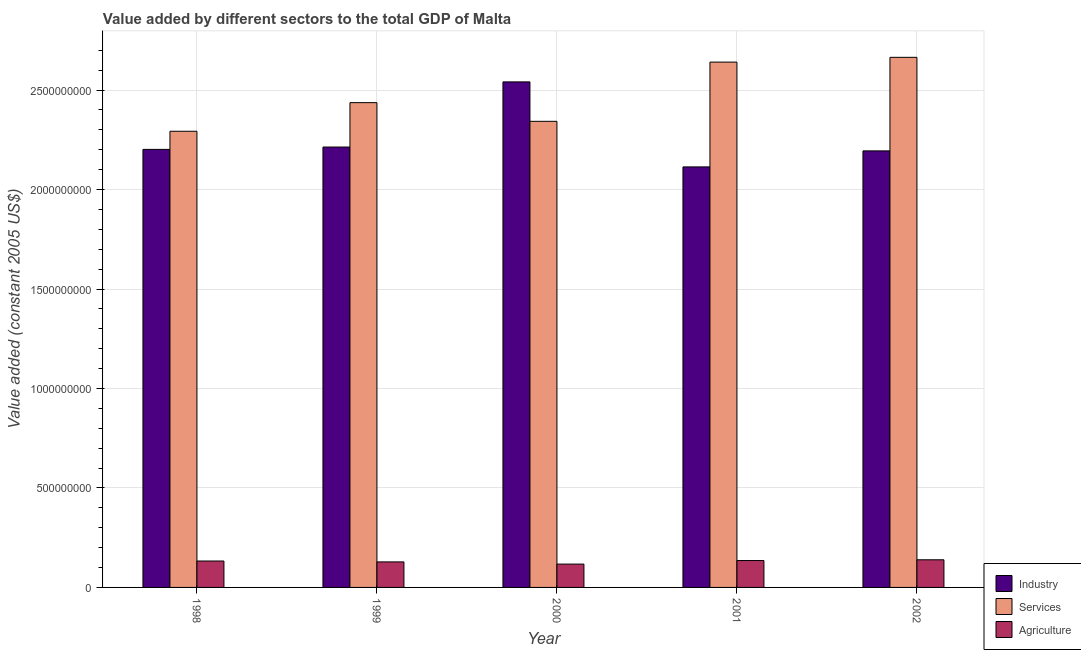How many groups of bars are there?
Ensure brevity in your answer.  5. Are the number of bars per tick equal to the number of legend labels?
Give a very brief answer. Yes. Are the number of bars on each tick of the X-axis equal?
Provide a short and direct response. Yes. How many bars are there on the 5th tick from the left?
Your answer should be compact. 3. How many bars are there on the 1st tick from the right?
Ensure brevity in your answer.  3. What is the label of the 4th group of bars from the left?
Ensure brevity in your answer.  2001. In how many cases, is the number of bars for a given year not equal to the number of legend labels?
Make the answer very short. 0. What is the value added by agricultural sector in 1998?
Your response must be concise. 1.33e+08. Across all years, what is the maximum value added by agricultural sector?
Make the answer very short. 1.39e+08. Across all years, what is the minimum value added by services?
Offer a terse response. 2.29e+09. In which year was the value added by industrial sector maximum?
Give a very brief answer. 2000. What is the total value added by agricultural sector in the graph?
Provide a succinct answer. 6.52e+08. What is the difference between the value added by industrial sector in 1998 and that in 2000?
Give a very brief answer. -3.39e+08. What is the difference between the value added by services in 2000 and the value added by industrial sector in 2001?
Give a very brief answer. -2.98e+08. What is the average value added by services per year?
Give a very brief answer. 2.48e+09. In how many years, is the value added by services greater than 900000000 US$?
Provide a short and direct response. 5. What is the ratio of the value added by services in 1998 to that in 2001?
Make the answer very short. 0.87. What is the difference between the highest and the second highest value added by services?
Provide a succinct answer. 2.40e+07. What is the difference between the highest and the lowest value added by industrial sector?
Provide a short and direct response. 4.27e+08. Is the sum of the value added by industrial sector in 1999 and 2001 greater than the maximum value added by services across all years?
Your answer should be very brief. Yes. What does the 1st bar from the left in 2001 represents?
Your response must be concise. Industry. What does the 2nd bar from the right in 1999 represents?
Provide a short and direct response. Services. Is it the case that in every year, the sum of the value added by industrial sector and value added by services is greater than the value added by agricultural sector?
Provide a succinct answer. Yes. How many years are there in the graph?
Provide a succinct answer. 5. Are the values on the major ticks of Y-axis written in scientific E-notation?
Your response must be concise. No. Does the graph contain any zero values?
Your answer should be very brief. No. Does the graph contain grids?
Offer a very short reply. Yes. What is the title of the graph?
Your response must be concise. Value added by different sectors to the total GDP of Malta. What is the label or title of the Y-axis?
Ensure brevity in your answer.  Value added (constant 2005 US$). What is the Value added (constant 2005 US$) of Industry in 1998?
Offer a terse response. 2.20e+09. What is the Value added (constant 2005 US$) of Services in 1998?
Provide a short and direct response. 2.29e+09. What is the Value added (constant 2005 US$) in Agriculture in 1998?
Give a very brief answer. 1.33e+08. What is the Value added (constant 2005 US$) of Industry in 1999?
Your answer should be compact. 2.21e+09. What is the Value added (constant 2005 US$) in Services in 1999?
Your response must be concise. 2.44e+09. What is the Value added (constant 2005 US$) of Agriculture in 1999?
Ensure brevity in your answer.  1.28e+08. What is the Value added (constant 2005 US$) of Industry in 2000?
Your response must be concise. 2.54e+09. What is the Value added (constant 2005 US$) in Services in 2000?
Offer a very short reply. 2.34e+09. What is the Value added (constant 2005 US$) in Agriculture in 2000?
Give a very brief answer. 1.17e+08. What is the Value added (constant 2005 US$) of Industry in 2001?
Provide a short and direct response. 2.11e+09. What is the Value added (constant 2005 US$) in Services in 2001?
Offer a terse response. 2.64e+09. What is the Value added (constant 2005 US$) in Agriculture in 2001?
Your response must be concise. 1.35e+08. What is the Value added (constant 2005 US$) in Industry in 2002?
Keep it short and to the point. 2.19e+09. What is the Value added (constant 2005 US$) of Services in 2002?
Give a very brief answer. 2.66e+09. What is the Value added (constant 2005 US$) of Agriculture in 2002?
Your answer should be compact. 1.39e+08. Across all years, what is the maximum Value added (constant 2005 US$) of Industry?
Your answer should be compact. 2.54e+09. Across all years, what is the maximum Value added (constant 2005 US$) in Services?
Offer a very short reply. 2.66e+09. Across all years, what is the maximum Value added (constant 2005 US$) of Agriculture?
Your answer should be very brief. 1.39e+08. Across all years, what is the minimum Value added (constant 2005 US$) of Industry?
Provide a succinct answer. 2.11e+09. Across all years, what is the minimum Value added (constant 2005 US$) in Services?
Your response must be concise. 2.29e+09. Across all years, what is the minimum Value added (constant 2005 US$) of Agriculture?
Your answer should be very brief. 1.17e+08. What is the total Value added (constant 2005 US$) in Industry in the graph?
Keep it short and to the point. 1.13e+1. What is the total Value added (constant 2005 US$) of Services in the graph?
Offer a terse response. 1.24e+1. What is the total Value added (constant 2005 US$) of Agriculture in the graph?
Provide a short and direct response. 6.52e+08. What is the difference between the Value added (constant 2005 US$) of Industry in 1998 and that in 1999?
Your answer should be compact. -1.18e+07. What is the difference between the Value added (constant 2005 US$) in Services in 1998 and that in 1999?
Your answer should be very brief. -1.44e+08. What is the difference between the Value added (constant 2005 US$) of Agriculture in 1998 and that in 1999?
Provide a succinct answer. 4.47e+06. What is the difference between the Value added (constant 2005 US$) in Industry in 1998 and that in 2000?
Offer a very short reply. -3.39e+08. What is the difference between the Value added (constant 2005 US$) of Services in 1998 and that in 2000?
Offer a very short reply. -4.99e+07. What is the difference between the Value added (constant 2005 US$) of Agriculture in 1998 and that in 2000?
Give a very brief answer. 1.54e+07. What is the difference between the Value added (constant 2005 US$) of Industry in 1998 and that in 2001?
Make the answer very short. 8.80e+07. What is the difference between the Value added (constant 2005 US$) in Services in 1998 and that in 2001?
Make the answer very short. -3.48e+08. What is the difference between the Value added (constant 2005 US$) in Agriculture in 1998 and that in 2001?
Make the answer very short. -2.40e+06. What is the difference between the Value added (constant 2005 US$) of Industry in 1998 and that in 2002?
Provide a short and direct response. 7.51e+06. What is the difference between the Value added (constant 2005 US$) in Services in 1998 and that in 2002?
Offer a terse response. -3.72e+08. What is the difference between the Value added (constant 2005 US$) in Agriculture in 1998 and that in 2002?
Your response must be concise. -6.11e+06. What is the difference between the Value added (constant 2005 US$) of Industry in 1999 and that in 2000?
Ensure brevity in your answer.  -3.28e+08. What is the difference between the Value added (constant 2005 US$) of Services in 1999 and that in 2000?
Make the answer very short. 9.39e+07. What is the difference between the Value added (constant 2005 US$) in Agriculture in 1999 and that in 2000?
Provide a succinct answer. 1.10e+07. What is the difference between the Value added (constant 2005 US$) in Industry in 1999 and that in 2001?
Provide a succinct answer. 9.98e+07. What is the difference between the Value added (constant 2005 US$) of Services in 1999 and that in 2001?
Ensure brevity in your answer.  -2.04e+08. What is the difference between the Value added (constant 2005 US$) in Agriculture in 1999 and that in 2001?
Your response must be concise. -6.88e+06. What is the difference between the Value added (constant 2005 US$) of Industry in 1999 and that in 2002?
Your answer should be very brief. 1.93e+07. What is the difference between the Value added (constant 2005 US$) of Services in 1999 and that in 2002?
Provide a short and direct response. -2.28e+08. What is the difference between the Value added (constant 2005 US$) in Agriculture in 1999 and that in 2002?
Offer a terse response. -1.06e+07. What is the difference between the Value added (constant 2005 US$) in Industry in 2000 and that in 2001?
Make the answer very short. 4.27e+08. What is the difference between the Value added (constant 2005 US$) of Services in 2000 and that in 2001?
Offer a very short reply. -2.98e+08. What is the difference between the Value added (constant 2005 US$) of Agriculture in 2000 and that in 2001?
Your answer should be compact. -1.78e+07. What is the difference between the Value added (constant 2005 US$) of Industry in 2000 and that in 2002?
Offer a terse response. 3.47e+08. What is the difference between the Value added (constant 2005 US$) of Services in 2000 and that in 2002?
Your answer should be compact. -3.22e+08. What is the difference between the Value added (constant 2005 US$) of Agriculture in 2000 and that in 2002?
Your response must be concise. -2.15e+07. What is the difference between the Value added (constant 2005 US$) in Industry in 2001 and that in 2002?
Make the answer very short. -8.05e+07. What is the difference between the Value added (constant 2005 US$) of Services in 2001 and that in 2002?
Make the answer very short. -2.40e+07. What is the difference between the Value added (constant 2005 US$) of Agriculture in 2001 and that in 2002?
Give a very brief answer. -3.71e+06. What is the difference between the Value added (constant 2005 US$) of Industry in 1998 and the Value added (constant 2005 US$) of Services in 1999?
Offer a very short reply. -2.35e+08. What is the difference between the Value added (constant 2005 US$) of Industry in 1998 and the Value added (constant 2005 US$) of Agriculture in 1999?
Offer a terse response. 2.07e+09. What is the difference between the Value added (constant 2005 US$) in Services in 1998 and the Value added (constant 2005 US$) in Agriculture in 1999?
Keep it short and to the point. 2.16e+09. What is the difference between the Value added (constant 2005 US$) of Industry in 1998 and the Value added (constant 2005 US$) of Services in 2000?
Ensure brevity in your answer.  -1.41e+08. What is the difference between the Value added (constant 2005 US$) of Industry in 1998 and the Value added (constant 2005 US$) of Agriculture in 2000?
Your answer should be compact. 2.08e+09. What is the difference between the Value added (constant 2005 US$) of Services in 1998 and the Value added (constant 2005 US$) of Agriculture in 2000?
Make the answer very short. 2.18e+09. What is the difference between the Value added (constant 2005 US$) in Industry in 1998 and the Value added (constant 2005 US$) in Services in 2001?
Provide a short and direct response. -4.39e+08. What is the difference between the Value added (constant 2005 US$) of Industry in 1998 and the Value added (constant 2005 US$) of Agriculture in 2001?
Offer a very short reply. 2.07e+09. What is the difference between the Value added (constant 2005 US$) in Services in 1998 and the Value added (constant 2005 US$) in Agriculture in 2001?
Make the answer very short. 2.16e+09. What is the difference between the Value added (constant 2005 US$) of Industry in 1998 and the Value added (constant 2005 US$) of Services in 2002?
Your answer should be very brief. -4.63e+08. What is the difference between the Value added (constant 2005 US$) in Industry in 1998 and the Value added (constant 2005 US$) in Agriculture in 2002?
Give a very brief answer. 2.06e+09. What is the difference between the Value added (constant 2005 US$) in Services in 1998 and the Value added (constant 2005 US$) in Agriculture in 2002?
Offer a very short reply. 2.15e+09. What is the difference between the Value added (constant 2005 US$) in Industry in 1999 and the Value added (constant 2005 US$) in Services in 2000?
Your response must be concise. -1.29e+08. What is the difference between the Value added (constant 2005 US$) of Industry in 1999 and the Value added (constant 2005 US$) of Agriculture in 2000?
Ensure brevity in your answer.  2.10e+09. What is the difference between the Value added (constant 2005 US$) of Services in 1999 and the Value added (constant 2005 US$) of Agriculture in 2000?
Your response must be concise. 2.32e+09. What is the difference between the Value added (constant 2005 US$) in Industry in 1999 and the Value added (constant 2005 US$) in Services in 2001?
Make the answer very short. -4.27e+08. What is the difference between the Value added (constant 2005 US$) in Industry in 1999 and the Value added (constant 2005 US$) in Agriculture in 2001?
Provide a succinct answer. 2.08e+09. What is the difference between the Value added (constant 2005 US$) in Services in 1999 and the Value added (constant 2005 US$) in Agriculture in 2001?
Provide a succinct answer. 2.30e+09. What is the difference between the Value added (constant 2005 US$) in Industry in 1999 and the Value added (constant 2005 US$) in Services in 2002?
Ensure brevity in your answer.  -4.51e+08. What is the difference between the Value added (constant 2005 US$) in Industry in 1999 and the Value added (constant 2005 US$) in Agriculture in 2002?
Provide a short and direct response. 2.07e+09. What is the difference between the Value added (constant 2005 US$) in Services in 1999 and the Value added (constant 2005 US$) in Agriculture in 2002?
Your response must be concise. 2.30e+09. What is the difference between the Value added (constant 2005 US$) of Industry in 2000 and the Value added (constant 2005 US$) of Services in 2001?
Ensure brevity in your answer.  -9.95e+07. What is the difference between the Value added (constant 2005 US$) of Industry in 2000 and the Value added (constant 2005 US$) of Agriculture in 2001?
Provide a succinct answer. 2.41e+09. What is the difference between the Value added (constant 2005 US$) in Services in 2000 and the Value added (constant 2005 US$) in Agriculture in 2001?
Keep it short and to the point. 2.21e+09. What is the difference between the Value added (constant 2005 US$) of Industry in 2000 and the Value added (constant 2005 US$) of Services in 2002?
Offer a terse response. -1.23e+08. What is the difference between the Value added (constant 2005 US$) of Industry in 2000 and the Value added (constant 2005 US$) of Agriculture in 2002?
Ensure brevity in your answer.  2.40e+09. What is the difference between the Value added (constant 2005 US$) in Services in 2000 and the Value added (constant 2005 US$) in Agriculture in 2002?
Offer a very short reply. 2.20e+09. What is the difference between the Value added (constant 2005 US$) of Industry in 2001 and the Value added (constant 2005 US$) of Services in 2002?
Make the answer very short. -5.51e+08. What is the difference between the Value added (constant 2005 US$) of Industry in 2001 and the Value added (constant 2005 US$) of Agriculture in 2002?
Your answer should be compact. 1.97e+09. What is the difference between the Value added (constant 2005 US$) in Services in 2001 and the Value added (constant 2005 US$) in Agriculture in 2002?
Your answer should be compact. 2.50e+09. What is the average Value added (constant 2005 US$) in Industry per year?
Ensure brevity in your answer.  2.25e+09. What is the average Value added (constant 2005 US$) in Services per year?
Your answer should be compact. 2.48e+09. What is the average Value added (constant 2005 US$) in Agriculture per year?
Your response must be concise. 1.30e+08. In the year 1998, what is the difference between the Value added (constant 2005 US$) of Industry and Value added (constant 2005 US$) of Services?
Offer a very short reply. -9.11e+07. In the year 1998, what is the difference between the Value added (constant 2005 US$) of Industry and Value added (constant 2005 US$) of Agriculture?
Give a very brief answer. 2.07e+09. In the year 1998, what is the difference between the Value added (constant 2005 US$) of Services and Value added (constant 2005 US$) of Agriculture?
Your answer should be very brief. 2.16e+09. In the year 1999, what is the difference between the Value added (constant 2005 US$) in Industry and Value added (constant 2005 US$) in Services?
Offer a very short reply. -2.23e+08. In the year 1999, what is the difference between the Value added (constant 2005 US$) of Industry and Value added (constant 2005 US$) of Agriculture?
Ensure brevity in your answer.  2.09e+09. In the year 1999, what is the difference between the Value added (constant 2005 US$) of Services and Value added (constant 2005 US$) of Agriculture?
Your answer should be compact. 2.31e+09. In the year 2000, what is the difference between the Value added (constant 2005 US$) in Industry and Value added (constant 2005 US$) in Services?
Provide a short and direct response. 1.98e+08. In the year 2000, what is the difference between the Value added (constant 2005 US$) in Industry and Value added (constant 2005 US$) in Agriculture?
Keep it short and to the point. 2.42e+09. In the year 2000, what is the difference between the Value added (constant 2005 US$) of Services and Value added (constant 2005 US$) of Agriculture?
Provide a succinct answer. 2.23e+09. In the year 2001, what is the difference between the Value added (constant 2005 US$) in Industry and Value added (constant 2005 US$) in Services?
Your answer should be very brief. -5.27e+08. In the year 2001, what is the difference between the Value added (constant 2005 US$) of Industry and Value added (constant 2005 US$) of Agriculture?
Your response must be concise. 1.98e+09. In the year 2001, what is the difference between the Value added (constant 2005 US$) of Services and Value added (constant 2005 US$) of Agriculture?
Your answer should be very brief. 2.51e+09. In the year 2002, what is the difference between the Value added (constant 2005 US$) in Industry and Value added (constant 2005 US$) in Services?
Keep it short and to the point. -4.70e+08. In the year 2002, what is the difference between the Value added (constant 2005 US$) in Industry and Value added (constant 2005 US$) in Agriculture?
Offer a terse response. 2.06e+09. In the year 2002, what is the difference between the Value added (constant 2005 US$) in Services and Value added (constant 2005 US$) in Agriculture?
Provide a succinct answer. 2.53e+09. What is the ratio of the Value added (constant 2005 US$) of Services in 1998 to that in 1999?
Keep it short and to the point. 0.94. What is the ratio of the Value added (constant 2005 US$) in Agriculture in 1998 to that in 1999?
Offer a terse response. 1.03. What is the ratio of the Value added (constant 2005 US$) in Industry in 1998 to that in 2000?
Make the answer very short. 0.87. What is the ratio of the Value added (constant 2005 US$) of Services in 1998 to that in 2000?
Provide a succinct answer. 0.98. What is the ratio of the Value added (constant 2005 US$) in Agriculture in 1998 to that in 2000?
Your answer should be compact. 1.13. What is the ratio of the Value added (constant 2005 US$) in Industry in 1998 to that in 2001?
Make the answer very short. 1.04. What is the ratio of the Value added (constant 2005 US$) in Services in 1998 to that in 2001?
Offer a very short reply. 0.87. What is the ratio of the Value added (constant 2005 US$) in Agriculture in 1998 to that in 2001?
Make the answer very short. 0.98. What is the ratio of the Value added (constant 2005 US$) in Industry in 1998 to that in 2002?
Give a very brief answer. 1. What is the ratio of the Value added (constant 2005 US$) in Services in 1998 to that in 2002?
Offer a very short reply. 0.86. What is the ratio of the Value added (constant 2005 US$) in Agriculture in 1998 to that in 2002?
Keep it short and to the point. 0.96. What is the ratio of the Value added (constant 2005 US$) in Industry in 1999 to that in 2000?
Your response must be concise. 0.87. What is the ratio of the Value added (constant 2005 US$) in Services in 1999 to that in 2000?
Provide a short and direct response. 1.04. What is the ratio of the Value added (constant 2005 US$) in Agriculture in 1999 to that in 2000?
Offer a terse response. 1.09. What is the ratio of the Value added (constant 2005 US$) in Industry in 1999 to that in 2001?
Offer a very short reply. 1.05. What is the ratio of the Value added (constant 2005 US$) of Services in 1999 to that in 2001?
Keep it short and to the point. 0.92. What is the ratio of the Value added (constant 2005 US$) of Agriculture in 1999 to that in 2001?
Make the answer very short. 0.95. What is the ratio of the Value added (constant 2005 US$) in Industry in 1999 to that in 2002?
Your response must be concise. 1.01. What is the ratio of the Value added (constant 2005 US$) of Services in 1999 to that in 2002?
Your response must be concise. 0.91. What is the ratio of the Value added (constant 2005 US$) in Agriculture in 1999 to that in 2002?
Keep it short and to the point. 0.92. What is the ratio of the Value added (constant 2005 US$) in Industry in 2000 to that in 2001?
Offer a very short reply. 1.2. What is the ratio of the Value added (constant 2005 US$) in Services in 2000 to that in 2001?
Your answer should be compact. 0.89. What is the ratio of the Value added (constant 2005 US$) of Agriculture in 2000 to that in 2001?
Provide a succinct answer. 0.87. What is the ratio of the Value added (constant 2005 US$) in Industry in 2000 to that in 2002?
Offer a very short reply. 1.16. What is the ratio of the Value added (constant 2005 US$) of Services in 2000 to that in 2002?
Ensure brevity in your answer.  0.88. What is the ratio of the Value added (constant 2005 US$) of Agriculture in 2000 to that in 2002?
Provide a short and direct response. 0.84. What is the ratio of the Value added (constant 2005 US$) of Industry in 2001 to that in 2002?
Your answer should be compact. 0.96. What is the ratio of the Value added (constant 2005 US$) of Agriculture in 2001 to that in 2002?
Your answer should be very brief. 0.97. What is the difference between the highest and the second highest Value added (constant 2005 US$) in Industry?
Offer a terse response. 3.28e+08. What is the difference between the highest and the second highest Value added (constant 2005 US$) in Services?
Make the answer very short. 2.40e+07. What is the difference between the highest and the second highest Value added (constant 2005 US$) in Agriculture?
Ensure brevity in your answer.  3.71e+06. What is the difference between the highest and the lowest Value added (constant 2005 US$) of Industry?
Your response must be concise. 4.27e+08. What is the difference between the highest and the lowest Value added (constant 2005 US$) of Services?
Your answer should be very brief. 3.72e+08. What is the difference between the highest and the lowest Value added (constant 2005 US$) of Agriculture?
Offer a very short reply. 2.15e+07. 